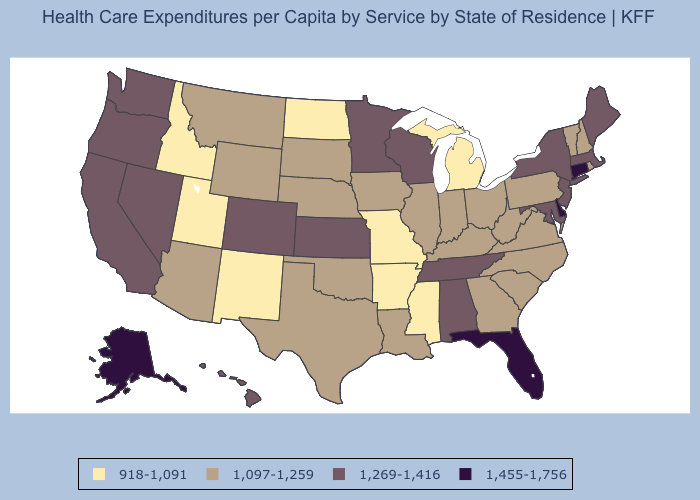What is the highest value in states that border Texas?
Be succinct. 1,097-1,259. Among the states that border Arizona , which have the lowest value?
Write a very short answer. New Mexico, Utah. Which states have the highest value in the USA?
Answer briefly. Alaska, Connecticut, Delaware, Florida. Does Kentucky have the lowest value in the USA?
Be succinct. No. What is the value of Montana?
Give a very brief answer. 1,097-1,259. Does Hawaii have a higher value than Colorado?
Answer briefly. No. Is the legend a continuous bar?
Keep it brief. No. How many symbols are there in the legend?
Concise answer only. 4. What is the value of Kentucky?
Concise answer only. 1,097-1,259. Name the states that have a value in the range 918-1,091?
Concise answer only. Arkansas, Idaho, Michigan, Mississippi, Missouri, New Mexico, North Dakota, Utah. Name the states that have a value in the range 1,269-1,416?
Give a very brief answer. Alabama, California, Colorado, Hawaii, Kansas, Maine, Maryland, Massachusetts, Minnesota, Nevada, New Jersey, New York, Oregon, Tennessee, Washington, Wisconsin. Does Rhode Island have the highest value in the USA?
Keep it brief. No. Among the states that border Tennessee , which have the highest value?
Short answer required. Alabama. Which states hav the highest value in the West?
Short answer required. Alaska. 